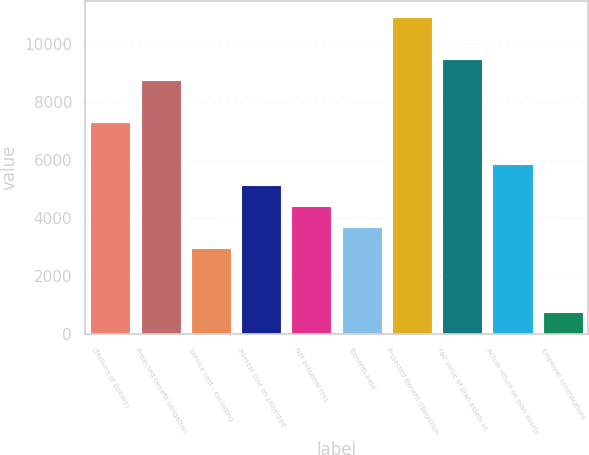Convert chart. <chart><loc_0><loc_0><loc_500><loc_500><bar_chart><fcel>(Millions of Dollars)<fcel>Projected benefit obligation<fcel>Service cost - excluding<fcel>Interest cost on projected<fcel>Net actuarial loss<fcel>Benefits paid<fcel>Projected Benefit Obligation<fcel>Fair value of plan assets at<fcel>Actual return on plan assets<fcel>Employer contributions<nl><fcel>7315<fcel>8772.8<fcel>2941.6<fcel>5128.3<fcel>4399.4<fcel>3670.5<fcel>10959.5<fcel>9501.7<fcel>5857.2<fcel>754.9<nl></chart> 